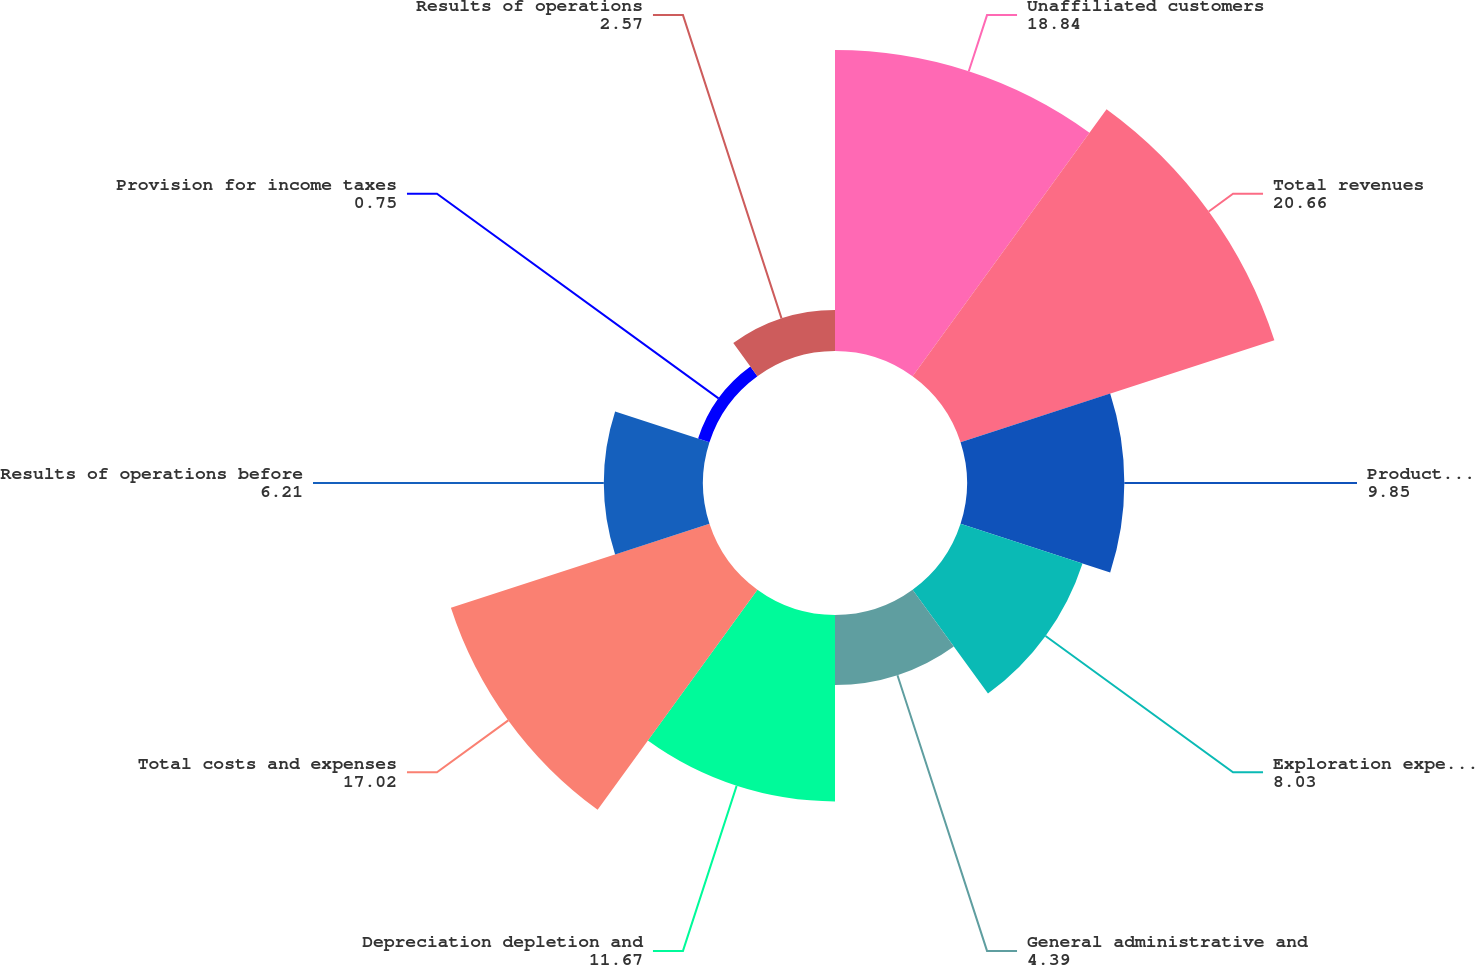Convert chart to OTSL. <chart><loc_0><loc_0><loc_500><loc_500><pie_chart><fcel>Unaffiliated customers<fcel>Total revenues<fcel>Production expenses including<fcel>Exploration expenses including<fcel>General administrative and<fcel>Depreciation depletion and<fcel>Total costs and expenses<fcel>Results of operations before<fcel>Provision for income taxes<fcel>Results of operations<nl><fcel>18.84%<fcel>20.66%<fcel>9.85%<fcel>8.03%<fcel>4.39%<fcel>11.67%<fcel>17.02%<fcel>6.21%<fcel>0.75%<fcel>2.57%<nl></chart> 